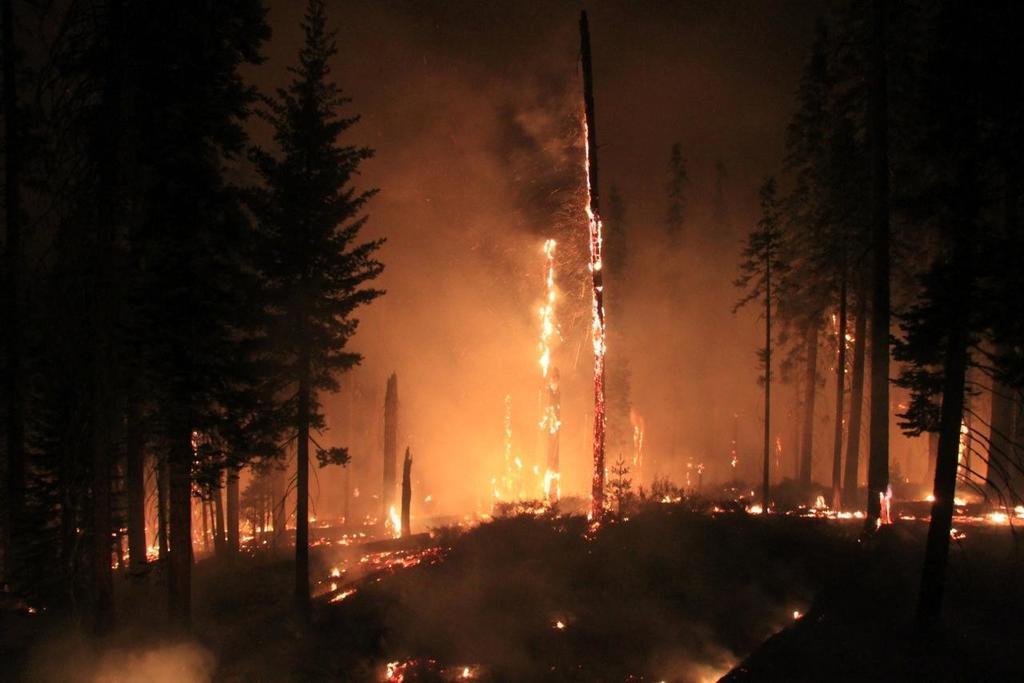How would you summarize this image in a sentence or two? On the left side, we see the trees. On the right side, we see the trees. In the middle of the picture, we see the fire. This picture is clicked in the dark. I think fire caught the forest. 